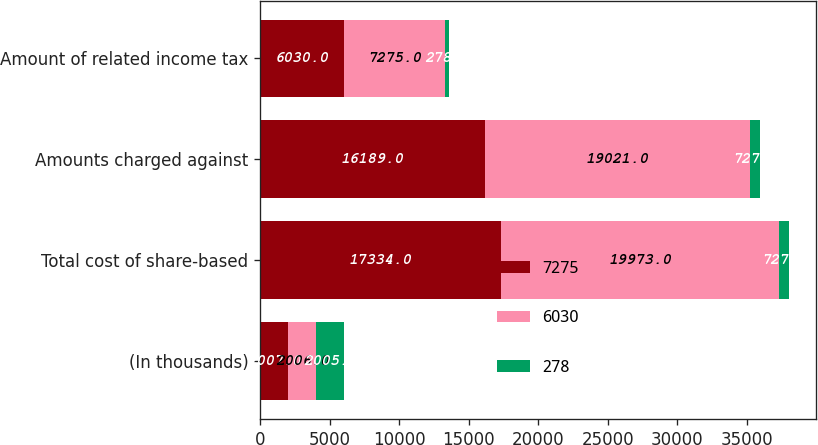Convert chart. <chart><loc_0><loc_0><loc_500><loc_500><stacked_bar_chart><ecel><fcel>(In thousands)<fcel>Total cost of share-based<fcel>Amounts charged against<fcel>Amount of related income tax<nl><fcel>7275<fcel>2007<fcel>17334<fcel>16189<fcel>6030<nl><fcel>6030<fcel>2006<fcel>19973<fcel>19021<fcel>7275<nl><fcel>278<fcel>2005<fcel>727<fcel>727<fcel>278<nl></chart> 